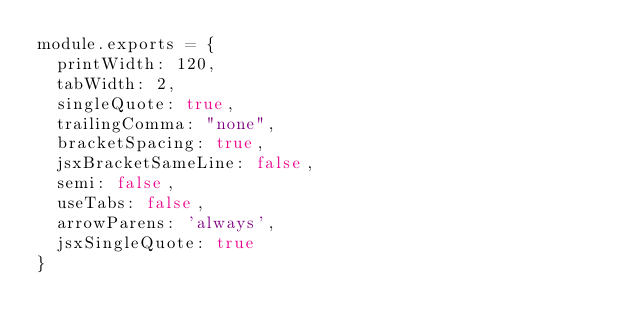Convert code to text. <code><loc_0><loc_0><loc_500><loc_500><_JavaScript_>module.exports = {
  printWidth: 120,
  tabWidth: 2,
  singleQuote: true,
  trailingComma: "none",
  bracketSpacing: true,
  jsxBracketSameLine: false,
  semi: false,
  useTabs: false,
  arrowParens: 'always',
  jsxSingleQuote: true
}
</code> 